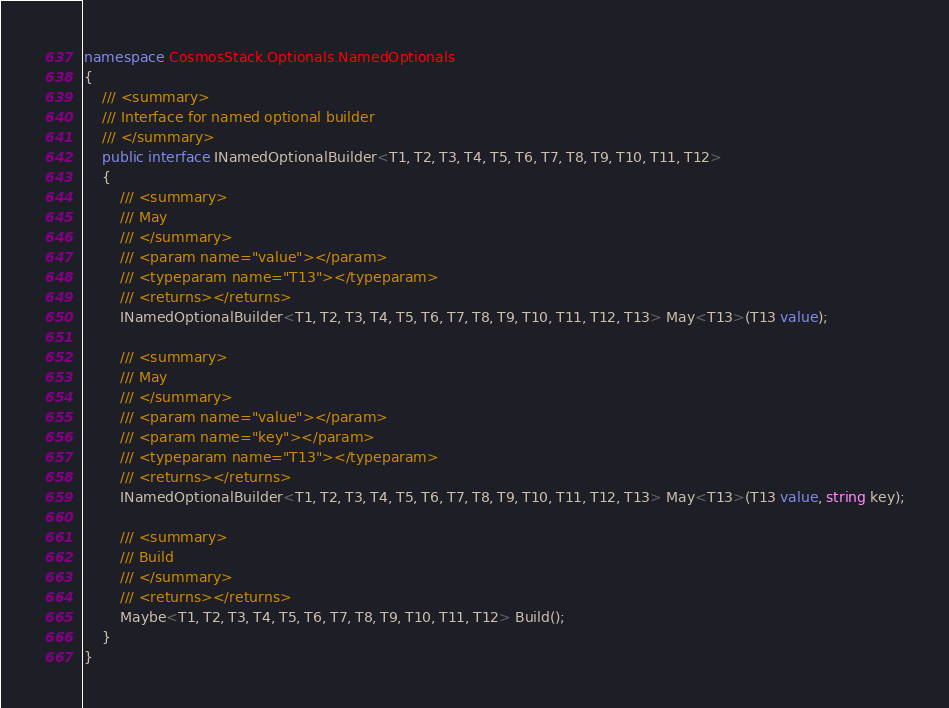<code> <loc_0><loc_0><loc_500><loc_500><_C#_>namespace CosmosStack.Optionals.NamedOptionals
{
    /// <summary>
    /// Interface for named optional builder
    /// </summary>
    public interface INamedOptionalBuilder<T1, T2, T3, T4, T5, T6, T7, T8, T9, T10, T11, T12>
    {
        /// <summary>
        /// May
        /// </summary>
        /// <param name="value"></param>
        /// <typeparam name="T13"></typeparam>
        /// <returns></returns>
        INamedOptionalBuilder<T1, T2, T3, T4, T5, T6, T7, T8, T9, T10, T11, T12, T13> May<T13>(T13 value);

        /// <summary>
        /// May
        /// </summary>
        /// <param name="value"></param>
        /// <param name="key"></param>
        /// <typeparam name="T13"></typeparam>
        /// <returns></returns>
        INamedOptionalBuilder<T1, T2, T3, T4, T5, T6, T7, T8, T9, T10, T11, T12, T13> May<T13>(T13 value, string key);

        /// <summary>
        /// Build
        /// </summary>
        /// <returns></returns>
        Maybe<T1, T2, T3, T4, T5, T6, T7, T8, T9, T10, T11, T12> Build();
    }
}</code> 